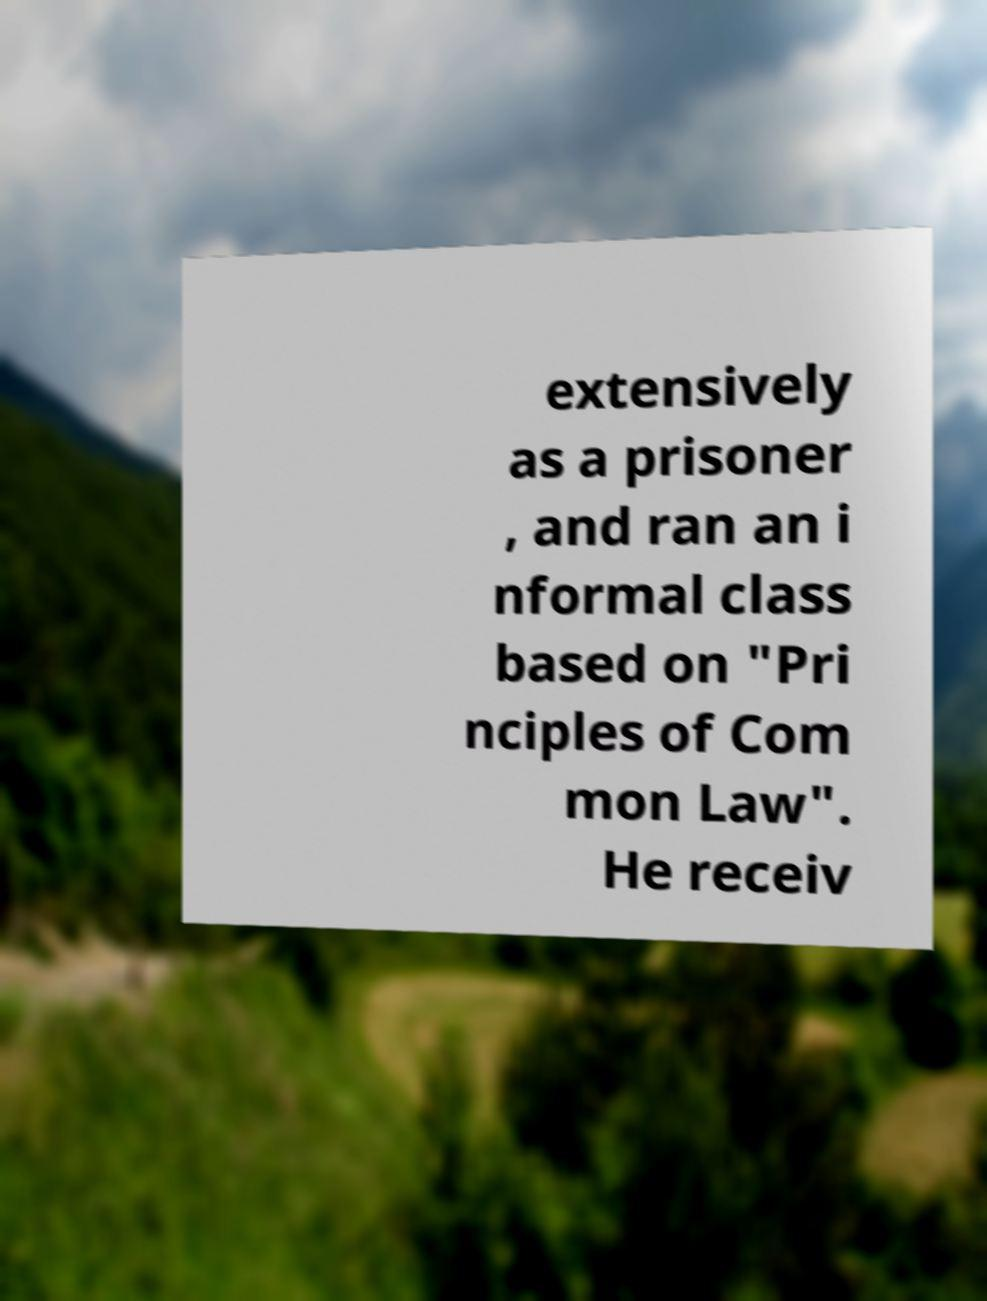Could you assist in decoding the text presented in this image and type it out clearly? extensively as a prisoner , and ran an i nformal class based on "Pri nciples of Com mon Law". He receiv 